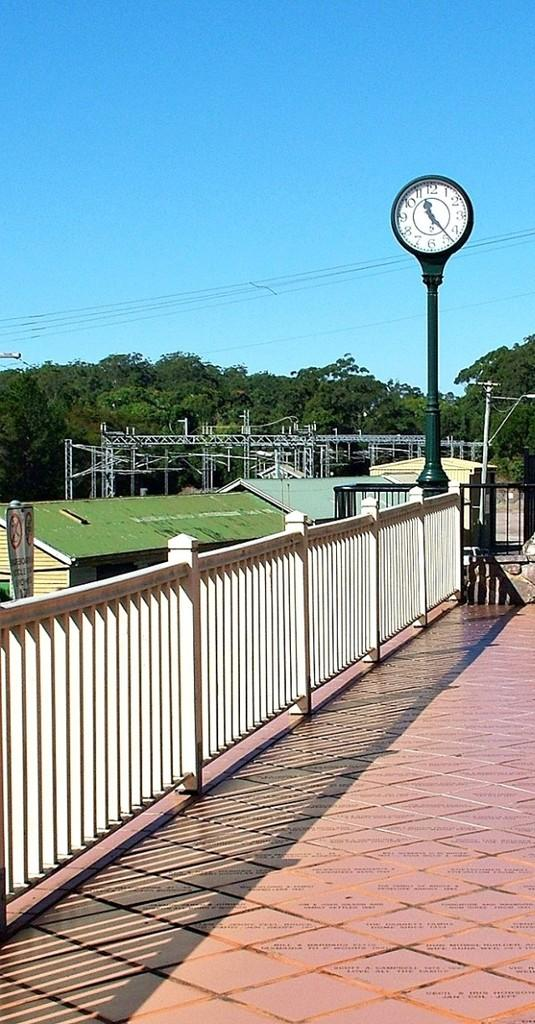What type of structure can be seen in the image? There is railing in the image. What object is attached to a pole in the image? There is a clock on a pole in the image. What type of buildings are present in the image? There are sheds in the image. What material are the poles made of in the image? Metal poles are present in the image. What type of vegetation is visible in the image? Trees are visible in the image. What else is present in the image besides the structures and vegetation? Wires are present in the image. What can be seen in the background of the image? The sky is visible in the background of the image. What type of operation is being performed on the dust in the image? There is no dust present in the image, and therefore no operation is being performed on it. What activity are the people engaged in while standing near the sheds in the image? The provided facts do not mention any people in the image, so we cannot determine what activity they might be engaged in. 